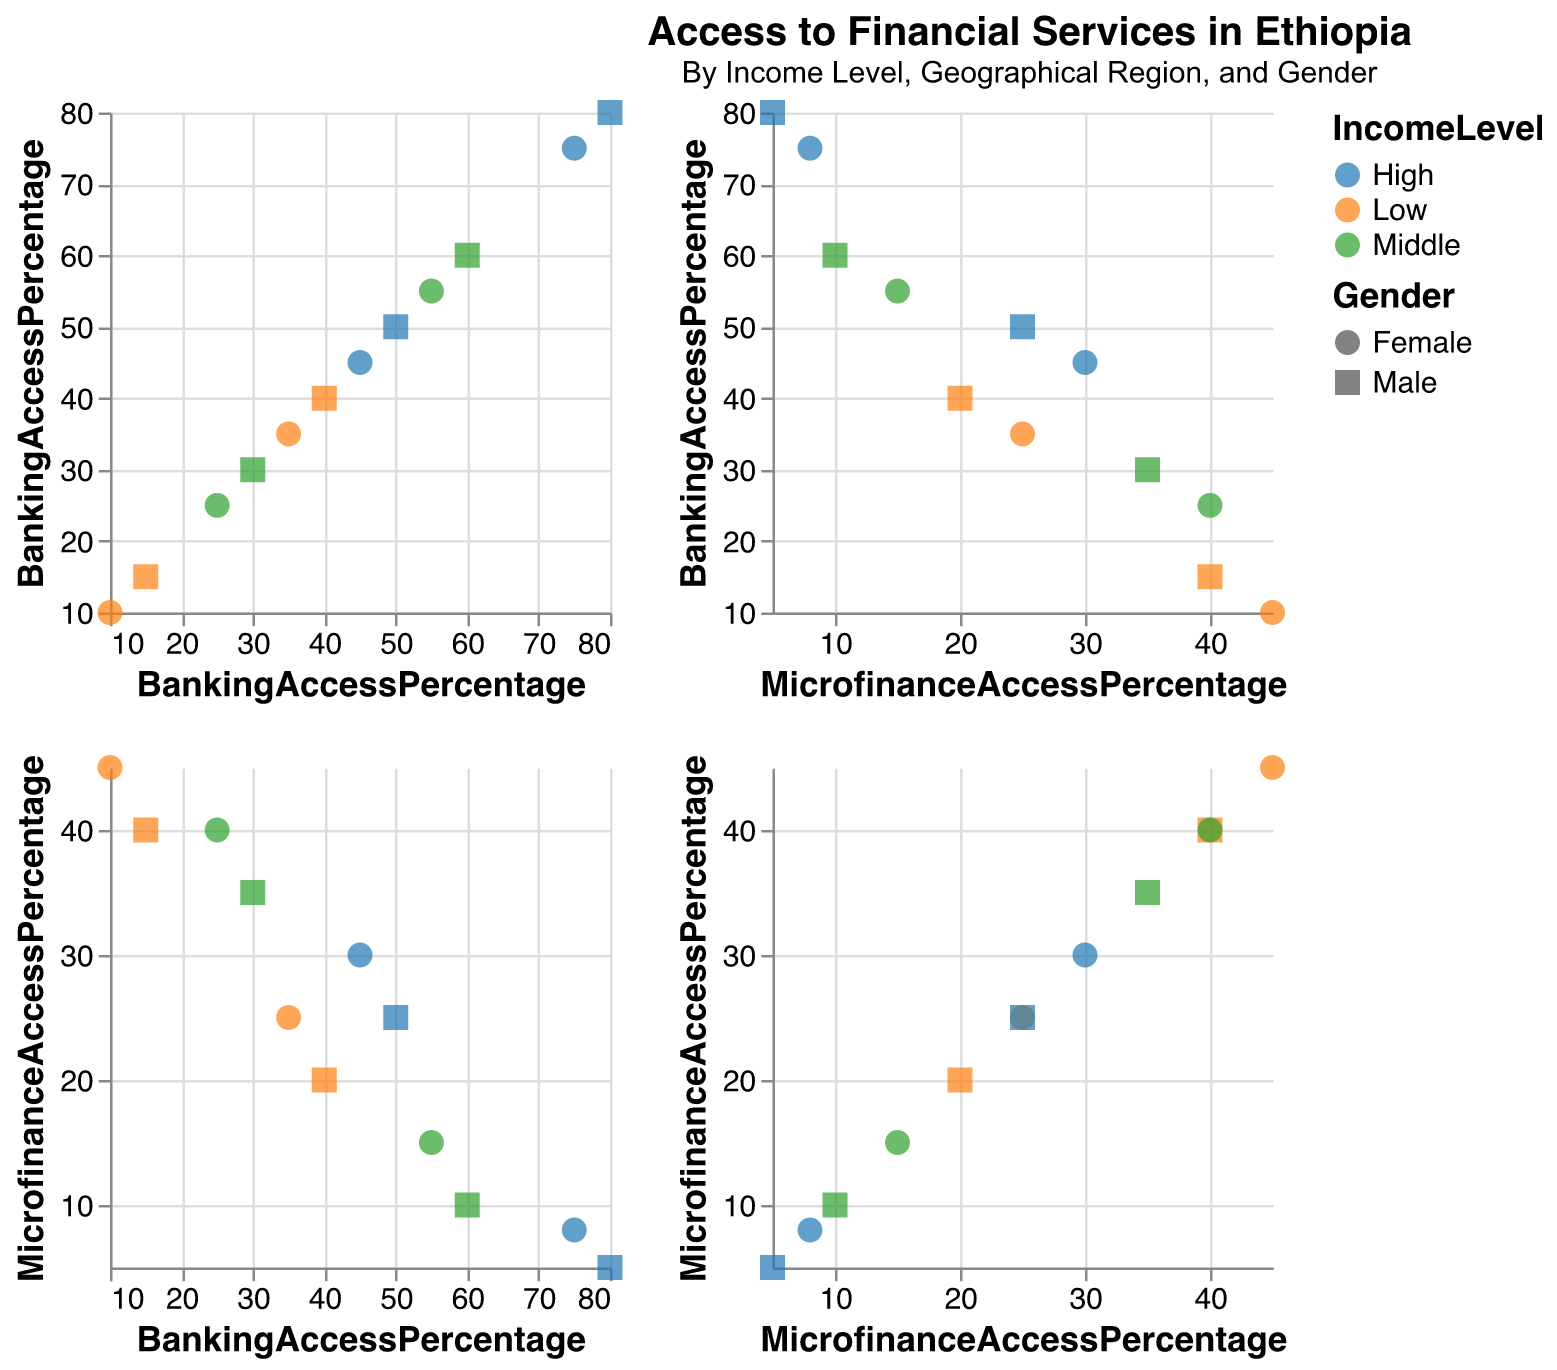What is the title of the scatter plot matrix? The title of the scatter plot matrix can be found at the top of the figure.
Answer: Access to Financial Services in Ethiopia How does banking access compare between high-income males and high-income females in urban areas? From the figure, high-income males in urban areas have 80% banking access, while high-income females in urban areas have 75% banking access.
Answer: High-income males have slightly higher banking access Which group has the highest microfinance access percentage in rural areas? By looking at the rural regions and comparing genders and income levels, low-income females have the highest microfinance access percentage at 45%.
Answer: Low-income females Is there a significant difference between banking access in urban and rural areas for middle-income males? For middle-income males, urban banking access is 60%, and rural banking access is 30%.
Answer: Yes, urban banking access is higher What is the average banking access percentage for low-income individuals in rural areas? Add the banking access percentages for low-income males and females in rural areas and divide by 2: (15 + 10) / 2 = 12.5%.
Answer: 12.5% Does gender have a noticeable impact on microfinance access in urban areas for high-income individuals? In urban areas, high-income males have 5% microfinance access, while high-income females have 8% microfinance access.
Answer: Yes, females have slightly higher access What is the banking access percentage for middle-income females in urban areas? The figure shows middle-income urban females with a banking access percentage of 55%.
Answer: 55% Compare microfinance access between low-income and middle-income females in rural areas. Low-income females have 45% microfinance access, while middle-income females have 40% microfinance access in rural areas.
Answer: Low-income females have higher access Is there a linear relationship between banking access and microfinance access across all groups? By examining the scatter plot matrix, there isn't an obvious straight-line correlation between banking access and microfinance access across all groups.
Answer: No Which income group shows the highest banking access in rural areas? By comparing income levels in rural areas, high-income males have the highest banking access at 50%.
Answer: High-income individuals 